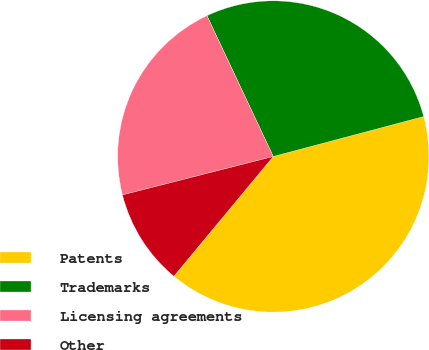<chart> <loc_0><loc_0><loc_500><loc_500><pie_chart><fcel>Patents<fcel>Trademarks<fcel>Licensing agreements<fcel>Other<nl><fcel>40.16%<fcel>27.88%<fcel>21.97%<fcel>10.0%<nl></chart> 